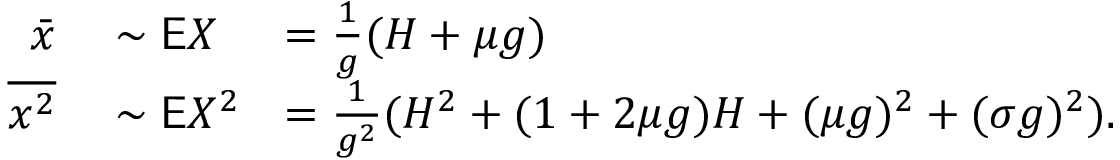<formula> <loc_0><loc_0><loc_500><loc_500>\begin{array} { r l r l } { \bar { x } } & \sim \mathsf E X } & \, = \frac { 1 } { g } ( H + \mu g ) } \\ { \overline { { x ^ { 2 } } } } & \sim \mathsf E X ^ { 2 } } & \, = \frac { 1 } { g ^ { 2 } } ( H ^ { 2 } + ( 1 + 2 \mu g ) H + ( \mu g ) ^ { 2 } + ( \sigma g ) ^ { 2 } ) . } \end{array}</formula> 